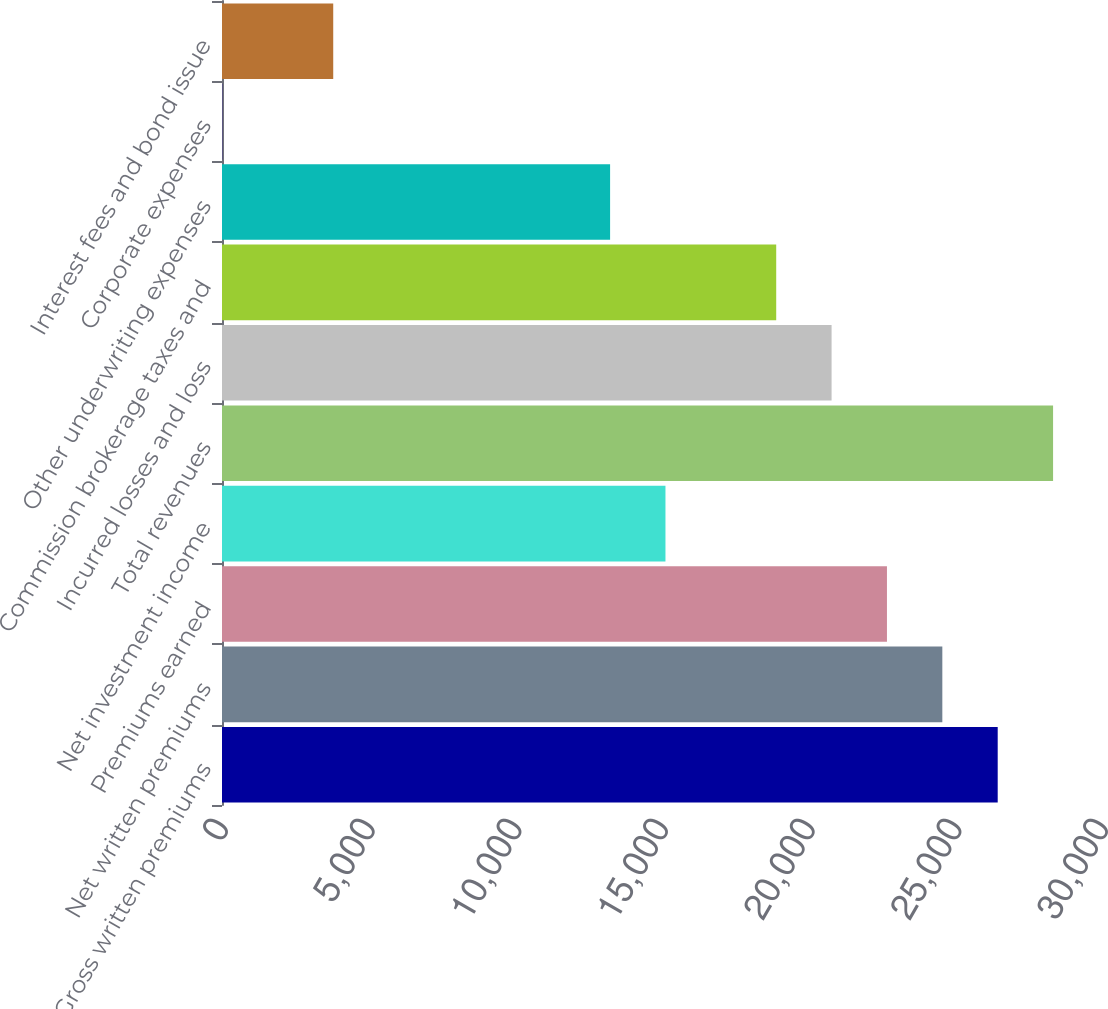Convert chart. <chart><loc_0><loc_0><loc_500><loc_500><bar_chart><fcel>Gross written premiums<fcel>Net written premiums<fcel>Premiums earned<fcel>Net investment income<fcel>Total revenues<fcel>Incurred losses and loss<fcel>Commission brokerage taxes and<fcel>Other underwriting expenses<fcel>Corporate expenses<fcel>Interest fees and bond issue<nl><fcel>26444.4<fcel>24556.7<fcel>22669<fcel>15118.2<fcel>28332.2<fcel>20781.3<fcel>18893.6<fcel>13230.5<fcel>16.5<fcel>3791.92<nl></chart> 